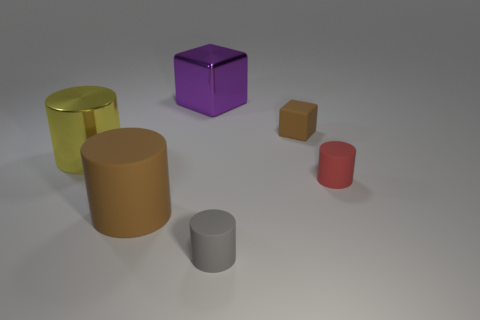What is the color of the matte object that is the same size as the purple shiny cube?
Your answer should be very brief. Brown. What number of other things are the same color as the matte block?
Provide a short and direct response. 1. Are there more gray cylinders that are in front of the big yellow metal thing than rubber objects?
Keep it short and to the point. No. Does the yellow object have the same material as the purple block?
Ensure brevity in your answer.  Yes. What number of things are rubber objects left of the small gray rubber cylinder or large gray spheres?
Keep it short and to the point. 1. What number of other things are the same size as the gray matte cylinder?
Ensure brevity in your answer.  2. Are there the same number of big brown rubber objects that are in front of the brown rubber cube and rubber cylinders that are behind the big yellow cylinder?
Offer a very short reply. No. What is the color of the other big rubber thing that is the same shape as the gray object?
Provide a short and direct response. Brown. Is there any other thing that has the same shape as the tiny brown rubber thing?
Offer a terse response. Yes. There is a matte thing that is to the left of the gray cylinder; is it the same color as the tiny rubber block?
Your response must be concise. Yes. 